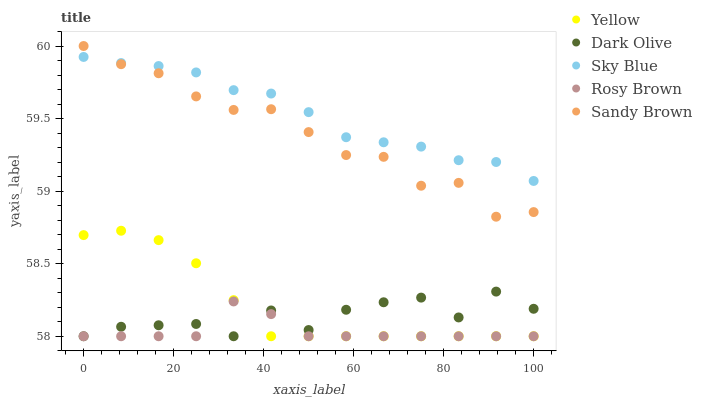Does Rosy Brown have the minimum area under the curve?
Answer yes or no. Yes. Does Sky Blue have the maximum area under the curve?
Answer yes or no. Yes. Does Dark Olive have the minimum area under the curve?
Answer yes or no. No. Does Dark Olive have the maximum area under the curve?
Answer yes or no. No. Is Yellow the smoothest?
Answer yes or no. Yes. Is Dark Olive the roughest?
Answer yes or no. Yes. Is Rosy Brown the smoothest?
Answer yes or no. No. Is Rosy Brown the roughest?
Answer yes or no. No. Does Rosy Brown have the lowest value?
Answer yes or no. Yes. Does Sandy Brown have the lowest value?
Answer yes or no. No. Does Sandy Brown have the highest value?
Answer yes or no. Yes. Does Dark Olive have the highest value?
Answer yes or no. No. Is Dark Olive less than Sandy Brown?
Answer yes or no. Yes. Is Sky Blue greater than Dark Olive?
Answer yes or no. Yes. Does Rosy Brown intersect Yellow?
Answer yes or no. Yes. Is Rosy Brown less than Yellow?
Answer yes or no. No. Is Rosy Brown greater than Yellow?
Answer yes or no. No. Does Dark Olive intersect Sandy Brown?
Answer yes or no. No. 